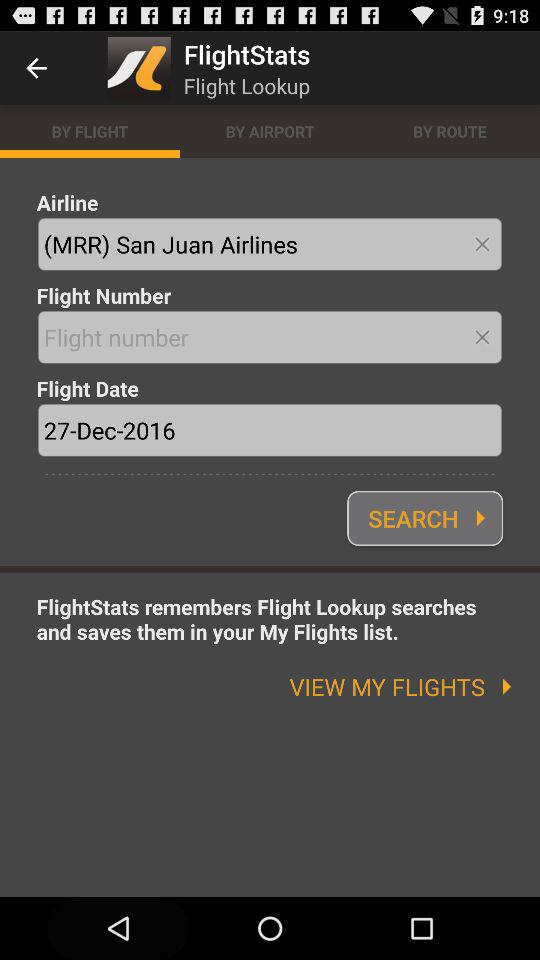Which tab is selected? The selected tab is "BY FLIGHT". 